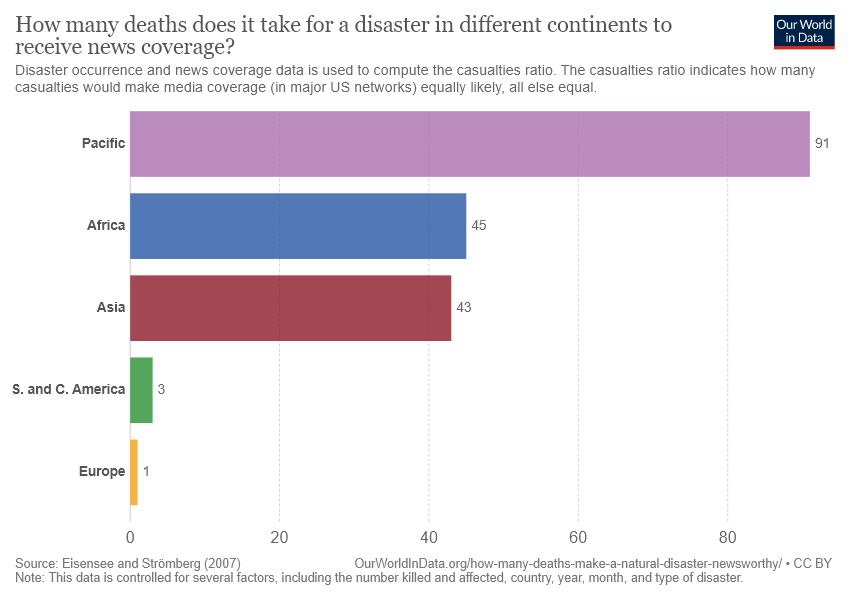Mention a couple of crucial points in this snapshot. The study aimed to determine the difference between the highest value and the median value of disaster occurrence and news coverage in the Philippines from 1948 to 2019. The country represented by the color blue, which has a value of 45, is Africa. 